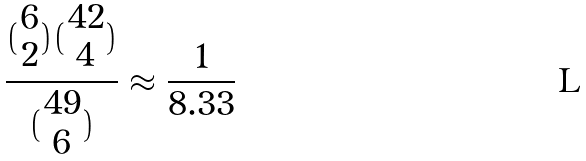Convert formula to latex. <formula><loc_0><loc_0><loc_500><loc_500>\frac { ( \begin{matrix} 6 \\ 2 \end{matrix} ) ( \begin{matrix} 4 2 \\ 4 \end{matrix} ) } { ( \begin{matrix} 4 9 \\ 6 \end{matrix} ) } \approx \frac { 1 } { 8 . 3 3 }</formula> 